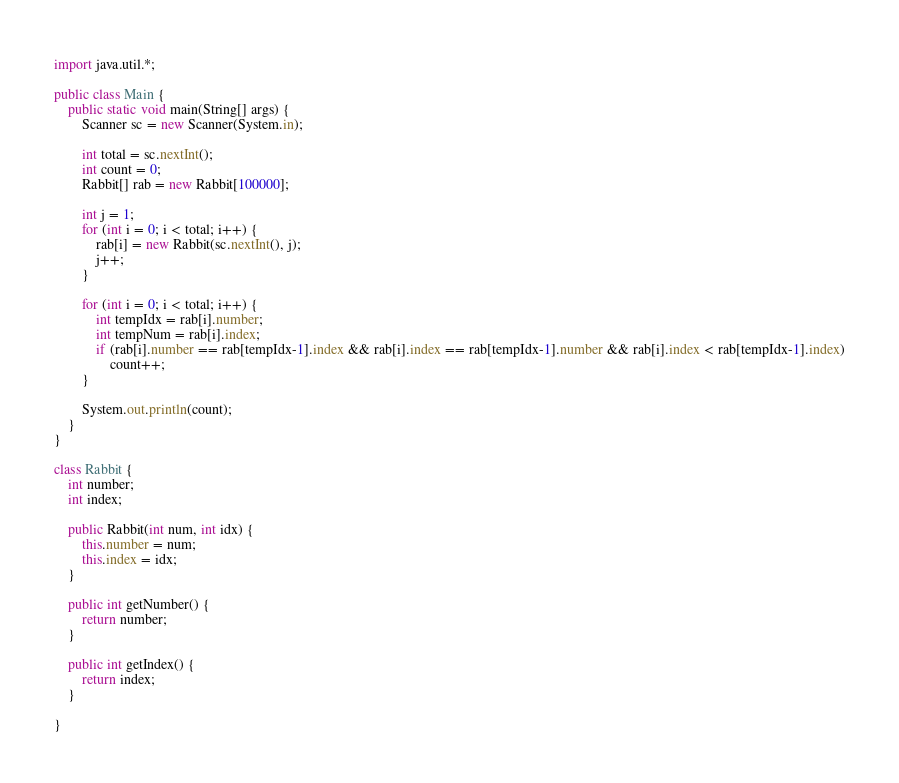Convert code to text. <code><loc_0><loc_0><loc_500><loc_500><_Java_>import java.util.*;

public class Main {
	public static void main(String[] args) {
		Scanner sc = new Scanner(System.in);
		
		int total = sc.nextInt();
		int count = 0;
		Rabbit[] rab = new Rabbit[100000];

		int j = 1;
		for (int i = 0; i < total; i++) {
			rab[i] = new Rabbit(sc.nextInt(), j);
			j++;
		}

		for (int i = 0; i < total; i++) {
			int tempIdx = rab[i].number;
			int tempNum = rab[i].index;
			if (rab[i].number == rab[tempIdx-1].index && rab[i].index == rab[tempIdx-1].number && rab[i].index < rab[tempIdx-1].index)
				count++;
		}

		System.out.println(count);
	}
}

class Rabbit {
	int number;
	int index;

	public Rabbit(int num, int idx) {
		this.number = num;
		this.index = idx;
	}

	public int getNumber() {
		return number;
	}

	public int getIndex() {
		return index;
	}

}</code> 